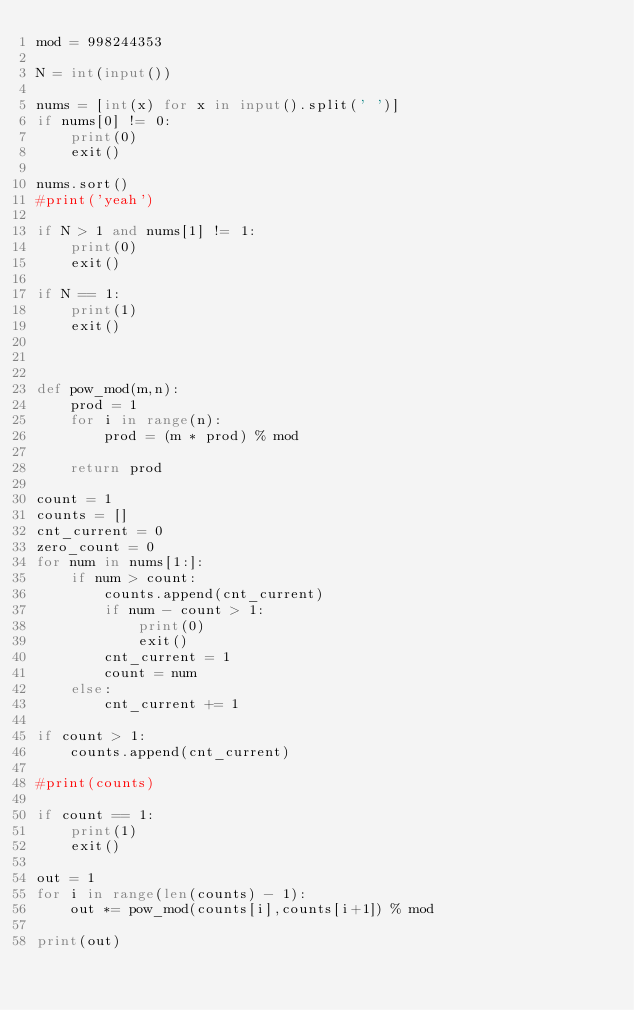Convert code to text. <code><loc_0><loc_0><loc_500><loc_500><_Python_>mod = 998244353

N = int(input())

nums = [int(x) for x in input().split(' ')]
if nums[0] != 0:
	print(0)
	exit()
	
nums.sort()
#print('yeah')

if N > 1 and nums[1] != 1:
	print(0)
	exit()
	
if N == 1:
	print(1)
	exit()
	


def pow_mod(m,n):
	prod = 1
	for i in range(n):
		prod = (m * prod) % mod
		
	return prod

count = 1
counts = []
cnt_current = 0
zero_count = 0
for num in nums[1:]:
	if num > count:
		counts.append(cnt_current)
		if num - count > 1:
			print(0)
			exit()
		cnt_current = 1
		count = num
	else:
		cnt_current += 1
		
if count > 1:
	counts.append(cnt_current)
		
#print(counts)
		
if count == 1:
	print(1)
	exit()
	
out = 1
for i in range(len(counts) - 1):
	out *= pow_mod(counts[i],counts[i+1]) % mod
	
print(out)
</code> 